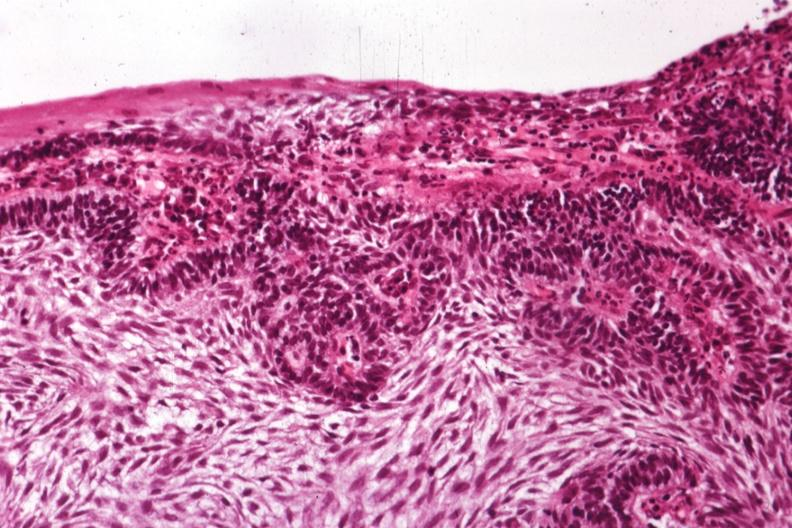s adenosis and ischemia present?
Answer the question using a single word or phrase. No 